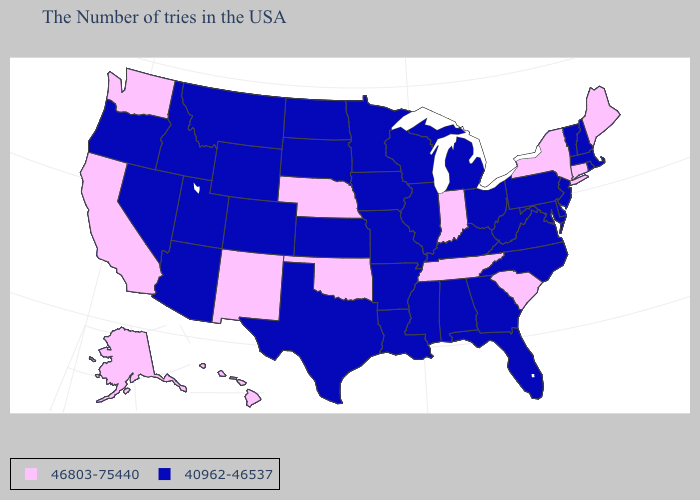Among the states that border Michigan , which have the highest value?
Give a very brief answer. Indiana. Among the states that border Oregon , which have the lowest value?
Be succinct. Idaho, Nevada. What is the highest value in states that border Kansas?
Be succinct. 46803-75440. How many symbols are there in the legend?
Answer briefly. 2. Name the states that have a value in the range 46803-75440?
Be succinct. Maine, Connecticut, New York, South Carolina, Indiana, Tennessee, Nebraska, Oklahoma, New Mexico, California, Washington, Alaska, Hawaii. Name the states that have a value in the range 40962-46537?
Keep it brief. Massachusetts, Rhode Island, New Hampshire, Vermont, New Jersey, Delaware, Maryland, Pennsylvania, Virginia, North Carolina, West Virginia, Ohio, Florida, Georgia, Michigan, Kentucky, Alabama, Wisconsin, Illinois, Mississippi, Louisiana, Missouri, Arkansas, Minnesota, Iowa, Kansas, Texas, South Dakota, North Dakota, Wyoming, Colorado, Utah, Montana, Arizona, Idaho, Nevada, Oregon. What is the value of Missouri?
Answer briefly. 40962-46537. Does Oklahoma have a higher value than Alaska?
Write a very short answer. No. What is the lowest value in the MidWest?
Answer briefly. 40962-46537. What is the value of Arkansas?
Quick response, please. 40962-46537. Does Alaska have the lowest value in the West?
Write a very short answer. No. Name the states that have a value in the range 46803-75440?
Give a very brief answer. Maine, Connecticut, New York, South Carolina, Indiana, Tennessee, Nebraska, Oklahoma, New Mexico, California, Washington, Alaska, Hawaii. Does Maryland have the same value as South Carolina?
Answer briefly. No. What is the highest value in states that border Massachusetts?
Be succinct. 46803-75440. 